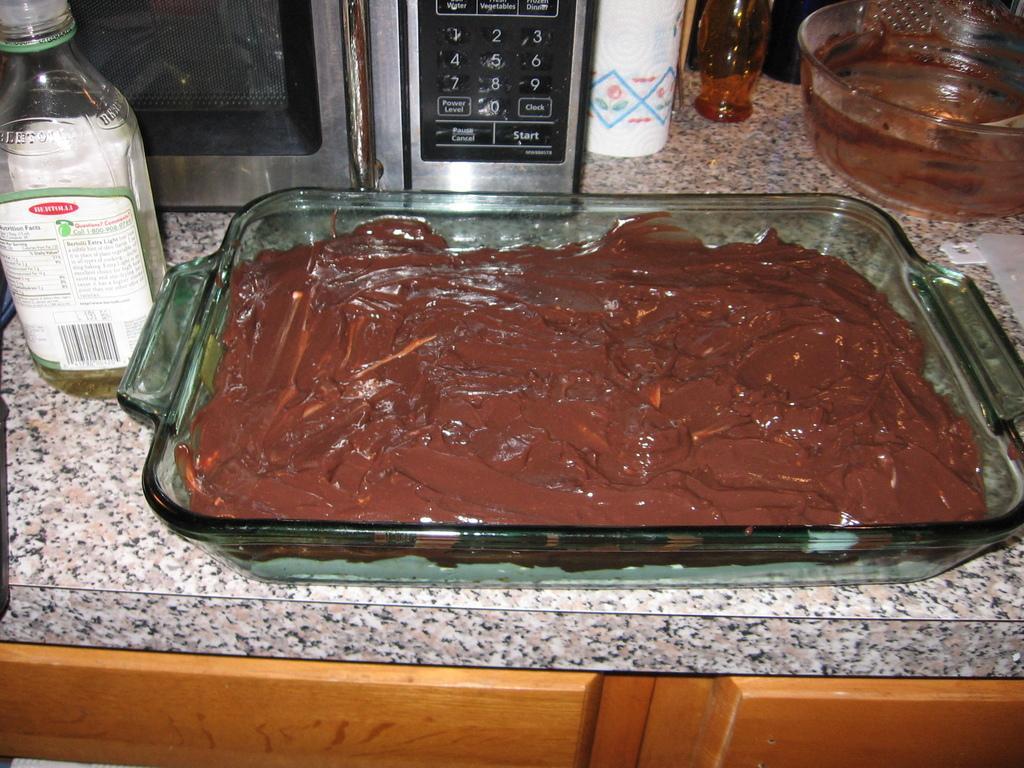In one or two sentences, can you explain what this image depicts? In the center we can see food item,bottle,microwave and some objects. 